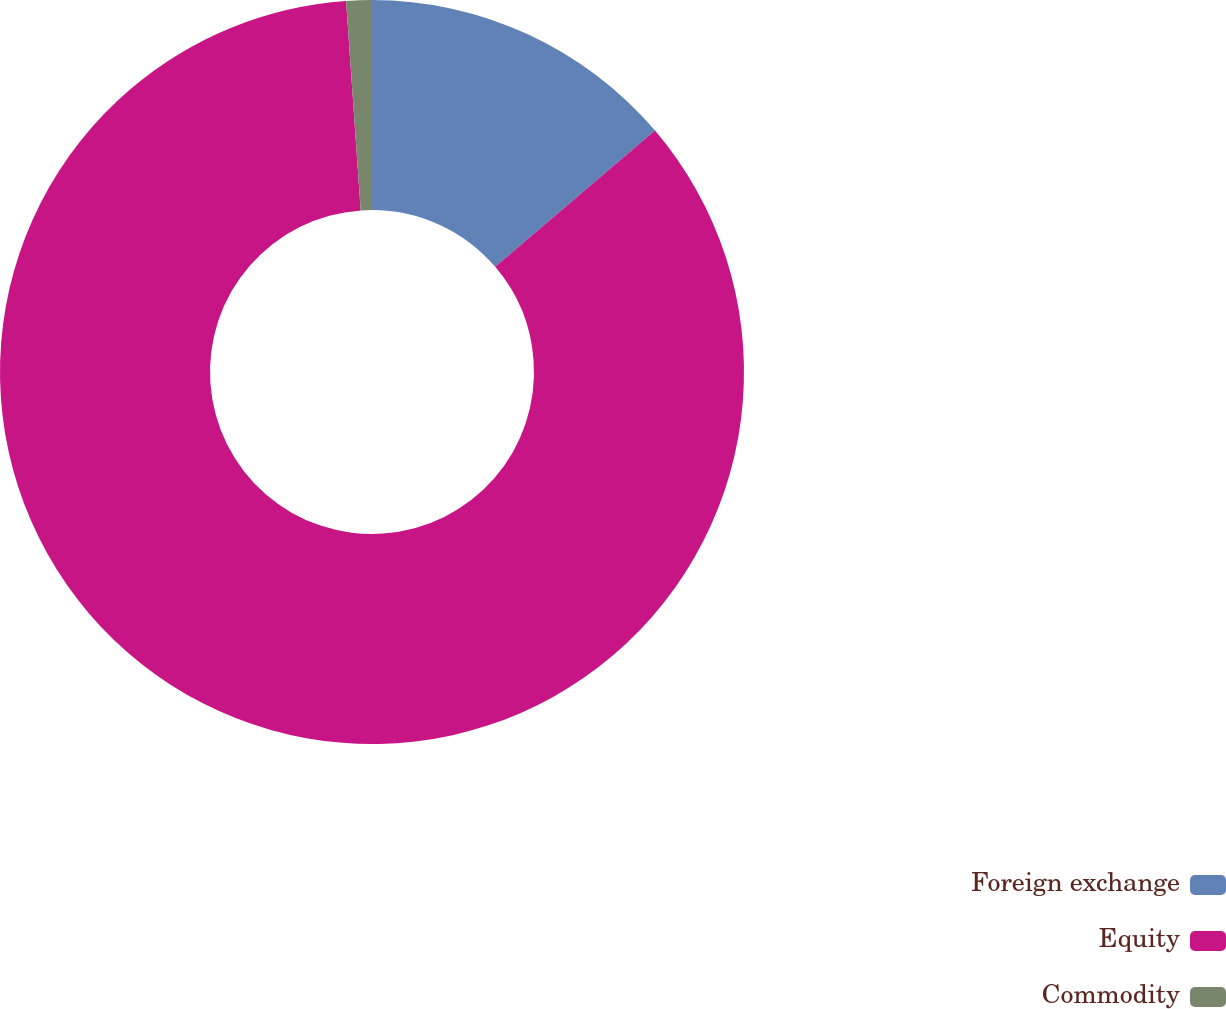Convert chart to OTSL. <chart><loc_0><loc_0><loc_500><loc_500><pie_chart><fcel>Foreign exchange<fcel>Equity<fcel>Commodity<nl><fcel>13.76%<fcel>85.13%<fcel>1.11%<nl></chart> 